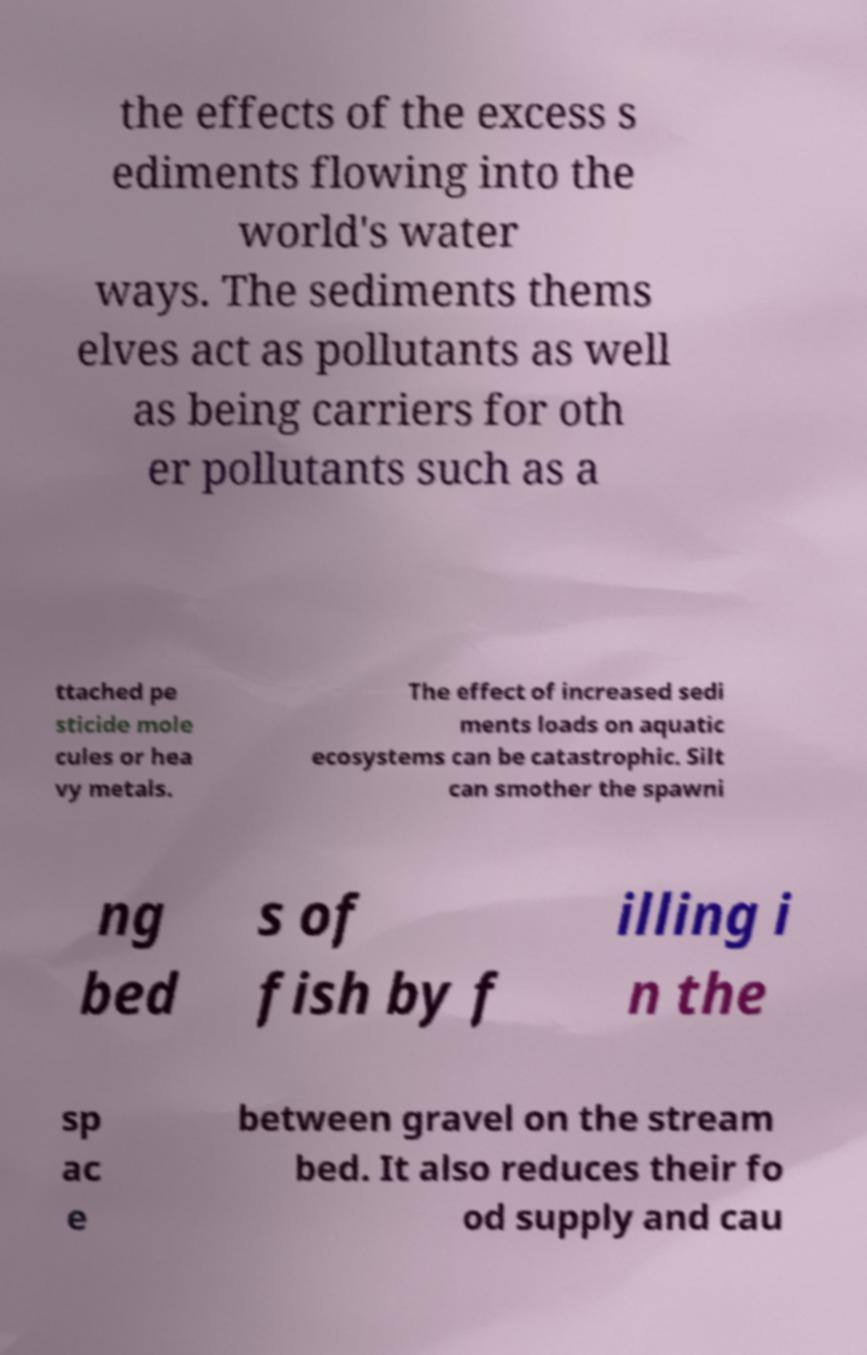There's text embedded in this image that I need extracted. Can you transcribe it verbatim? the effects of the excess s ediments flowing into the world's water ways. The sediments thems elves act as pollutants as well as being carriers for oth er pollutants such as a ttached pe sticide mole cules or hea vy metals. The effect of increased sedi ments loads on aquatic ecosystems can be catastrophic. Silt can smother the spawni ng bed s of fish by f illing i n the sp ac e between gravel on the stream bed. It also reduces their fo od supply and cau 